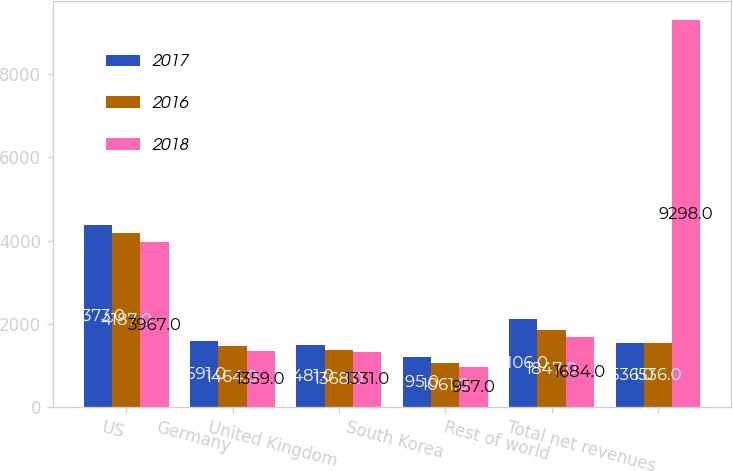Convert chart. <chart><loc_0><loc_0><loc_500><loc_500><stacked_bar_chart><ecel><fcel>US<fcel>Germany<fcel>United Kingdom<fcel>South Korea<fcel>Rest of world<fcel>Total net revenues<nl><fcel>2017<fcel>4373<fcel>1591<fcel>1481<fcel>1195<fcel>2106<fcel>1536<nl><fcel>2016<fcel>4187<fcel>1464<fcel>1368<fcel>1061<fcel>1847<fcel>1536<nl><fcel>2018<fcel>3967<fcel>1359<fcel>1331<fcel>957<fcel>1684<fcel>9298<nl></chart> 